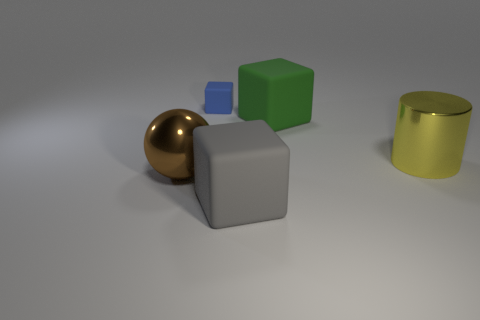Do the big thing in front of the brown shiny ball and the brown sphere have the same material? no 